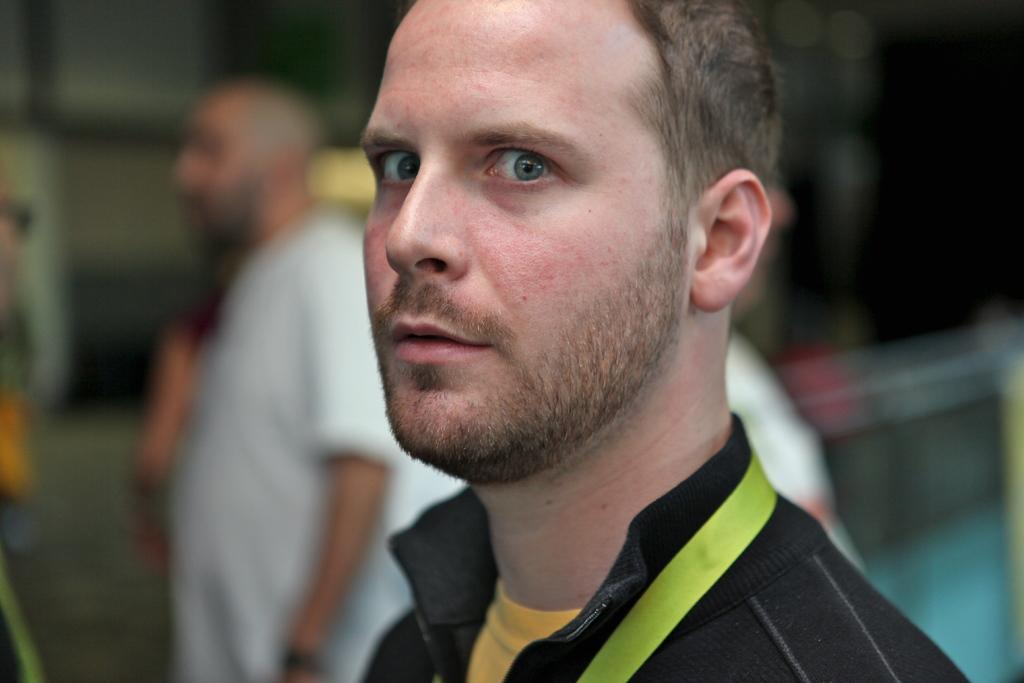What is the main subject in the foreground of the image? There is a person in the foreground of the image. What is the person wearing in the image? The person is wearing a black jacket. What can be seen in the background of the image? There are people in the background of the image. How is the background of the image depicted? The background of the image is blurred. What type of balls are being juggled by the person in the image? There are no balls present in the image, and the person is not juggling anything. What is inside the sack that the person is carrying in the image? There is no sack visible in the image, and the person is not carrying anything. 